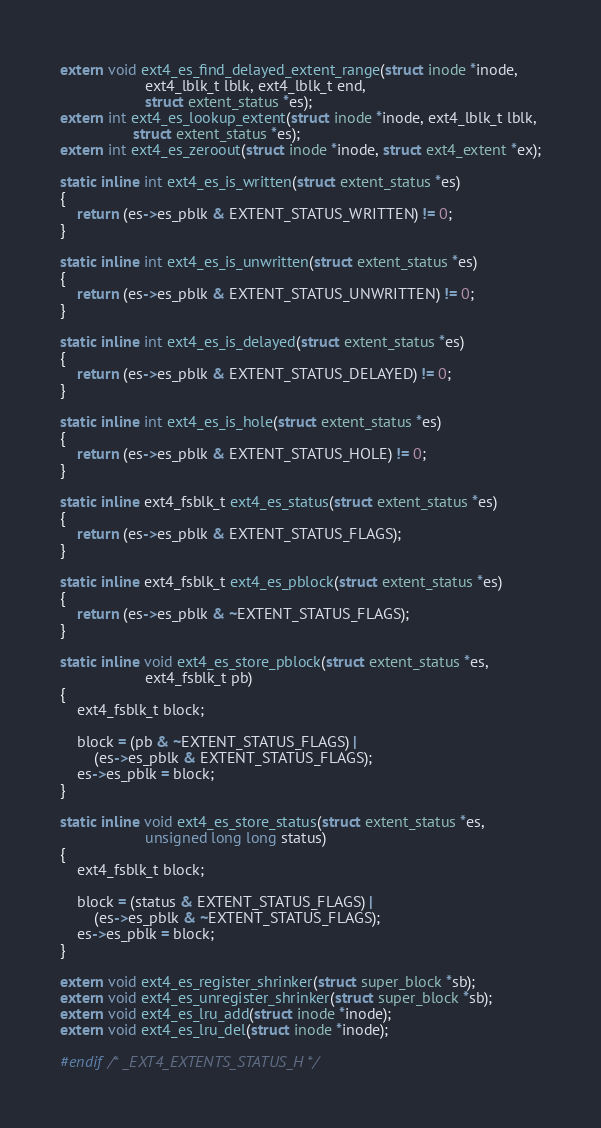<code> <loc_0><loc_0><loc_500><loc_500><_C_>extern void ext4_es_find_delayed_extent_range(struct inode *inode,
					ext4_lblk_t lblk, ext4_lblk_t end,
					struct extent_status *es);
extern int ext4_es_lookup_extent(struct inode *inode, ext4_lblk_t lblk,
				 struct extent_status *es);
extern int ext4_es_zeroout(struct inode *inode, struct ext4_extent *ex);

static inline int ext4_es_is_written(struct extent_status *es)
{
	return (es->es_pblk & EXTENT_STATUS_WRITTEN) != 0;
}

static inline int ext4_es_is_unwritten(struct extent_status *es)
{
	return (es->es_pblk & EXTENT_STATUS_UNWRITTEN) != 0;
}

static inline int ext4_es_is_delayed(struct extent_status *es)
{
	return (es->es_pblk & EXTENT_STATUS_DELAYED) != 0;
}

static inline int ext4_es_is_hole(struct extent_status *es)
{
	return (es->es_pblk & EXTENT_STATUS_HOLE) != 0;
}

static inline ext4_fsblk_t ext4_es_status(struct extent_status *es)
{
	return (es->es_pblk & EXTENT_STATUS_FLAGS);
}

static inline ext4_fsblk_t ext4_es_pblock(struct extent_status *es)
{
	return (es->es_pblk & ~EXTENT_STATUS_FLAGS);
}

static inline void ext4_es_store_pblock(struct extent_status *es,
					ext4_fsblk_t pb)
{
	ext4_fsblk_t block;

	block = (pb & ~EXTENT_STATUS_FLAGS) |
		(es->es_pblk & EXTENT_STATUS_FLAGS);
	es->es_pblk = block;
}

static inline void ext4_es_store_status(struct extent_status *es,
					unsigned long long status)
{
	ext4_fsblk_t block;

	block = (status & EXTENT_STATUS_FLAGS) |
		(es->es_pblk & ~EXTENT_STATUS_FLAGS);
	es->es_pblk = block;
}

extern void ext4_es_register_shrinker(struct super_block *sb);
extern void ext4_es_unregister_shrinker(struct super_block *sb);
extern void ext4_es_lru_add(struct inode *inode);
extern void ext4_es_lru_del(struct inode *inode);

#endif /* _EXT4_EXTENTS_STATUS_H */
</code> 